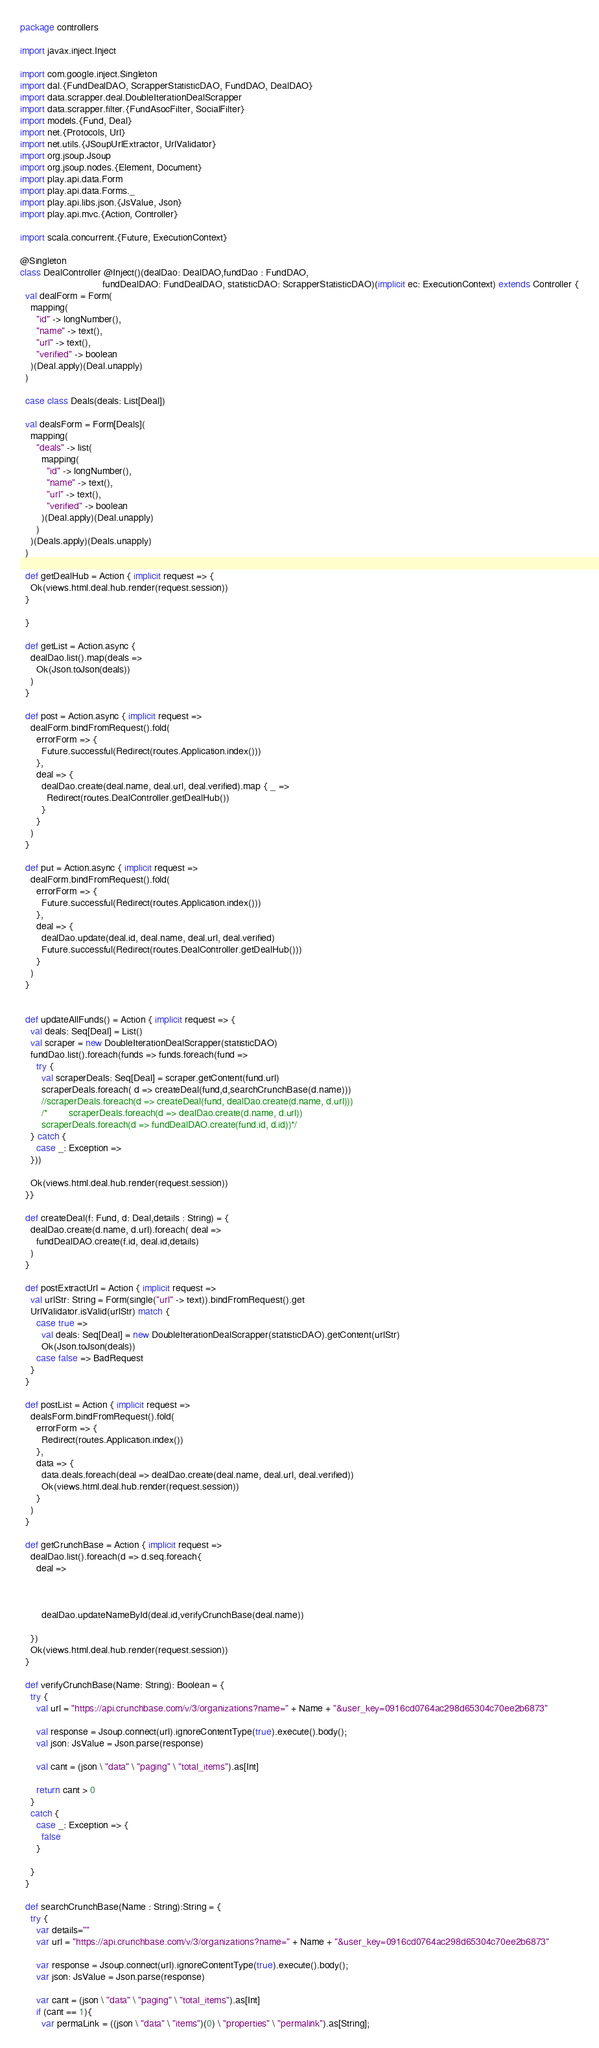Convert code to text. <code><loc_0><loc_0><loc_500><loc_500><_Scala_>package controllers

import javax.inject.Inject

import com.google.inject.Singleton
import dal.{FundDealDAO, ScrapperStatisticDAO, FundDAO, DealDAO}
import data.scrapper.deal.DoubleIterationDealScrapper
import data.scrapper.filter.{FundAsocFilter, SocialFilter}
import models.{Fund, Deal}
import net.{Protocols, Url}
import net.utils.{JSoupUrlExtractor, UrlValidator}
import org.jsoup.Jsoup
import org.jsoup.nodes.{Element, Document}
import play.api.data.Form
import play.api.data.Forms._
import play.api.libs.json.{JsValue, Json}
import play.api.mvc.{Action, Controller}

import scala.concurrent.{Future, ExecutionContext}

@Singleton
class DealController @Inject()(dealDao: DealDAO,fundDao : FundDAO,
                               fundDealDAO: FundDealDAO, statisticDAO: ScrapperStatisticDAO)(implicit ec: ExecutionContext) extends Controller {
  val dealForm = Form(
    mapping(
      "id" -> longNumber(),
      "name" -> text(),
      "url" -> text(),
      "verified" -> boolean
    )(Deal.apply)(Deal.unapply)
  )

  case class Deals(deals: List[Deal])

  val dealsForm = Form[Deals](
    mapping(
      "deals" -> list(
        mapping(
          "id" -> longNumber(),
          "name" -> text(),
          "url" -> text(),
          "verified" -> boolean
        )(Deal.apply)(Deal.unapply)
      )
    )(Deals.apply)(Deals.unapply)
  )

  def getDealHub = Action { implicit request => {
    Ok(views.html.deal.hub.render(request.session))
  }

  }

  def getList = Action.async {
    dealDao.list().map(deals =>
      Ok(Json.toJson(deals))
    )
  }

  def post = Action.async { implicit request =>
    dealForm.bindFromRequest().fold(
      errorForm => {
        Future.successful(Redirect(routes.Application.index()))
      },
      deal => {
        dealDao.create(deal.name, deal.url, deal.verified).map { _ =>
          Redirect(routes.DealController.getDealHub())
        }
      }
    )
  }

  def put = Action.async { implicit request =>
    dealForm.bindFromRequest().fold(
      errorForm => {
        Future.successful(Redirect(routes.Application.index()))
      },
      deal => {
        dealDao.update(deal.id, deal.name, deal.url, deal.verified)
        Future.successful(Redirect(routes.DealController.getDealHub()))
      }
    )
  }


  def updateAllFunds() = Action { implicit request => {
    val deals: Seq[Deal] = List()
    val scraper = new DoubleIterationDealScrapper(statisticDAO)
    fundDao.list().foreach(funds => funds.foreach(fund =>
      try {
        val scraperDeals: Seq[Deal] = scraper.getContent(fund.url)
        scraperDeals.foreach( d => createDeal(fund,d,searchCrunchBase(d.name)))
        //scraperDeals.foreach(d => createDeal(fund, dealDao.create(d.name, d.url)))
        /*        scraperDeals.foreach(d => dealDao.create(d.name, d.url))
        scraperDeals.foreach(d => fundDealDAO.create(fund.id, d.id))*/
    } catch {
      case _: Exception =>
    }))

    Ok(views.html.deal.hub.render(request.session))
  }}

  def createDeal(f: Fund, d: Deal,details : String) = {
    dealDao.create(d.name, d.url).foreach( deal =>
      fundDealDAO.create(f.id, deal.id,details)
    )
  }

  def postExtractUrl = Action { implicit request =>
    val urlStr: String = Form(single("url" -> text)).bindFromRequest().get
    UrlValidator.isValid(urlStr) match {
      case true =>
        val deals: Seq[Deal] = new DoubleIterationDealScrapper(statisticDAO).getContent(urlStr)
        Ok(Json.toJson(deals))
      case false => BadRequest
    }
  }

  def postList = Action { implicit request =>
    dealsForm.bindFromRequest().fold(
      errorForm => {
        Redirect(routes.Application.index())
      },
      data => {
        data.deals.foreach(deal => dealDao.create(deal.name, deal.url, deal.verified))
        Ok(views.html.deal.hub.render(request.session))
      }
    )
  }

  def getCrunchBase = Action { implicit request =>
    dealDao.list().foreach(d => d.seq.foreach{
      deal =>



        dealDao.updateNameById(deal.id,verifyCrunchBase(deal.name))

    })
    Ok(views.html.deal.hub.render(request.session))
  }

  def verifyCrunchBase(Name: String): Boolean = {
    try {
      val url = "https://api.crunchbase.com/v/3/organizations?name=" + Name + "&user_key=0916cd0764ac298d65304c70ee2b6873"

      val response = Jsoup.connect(url).ignoreContentType(true).execute().body();
      val json: JsValue = Json.parse(response)

      val cant = (json \ "data" \ "paging" \ "total_items").as[Int]

      return cant > 0
    }
    catch {
      case _: Exception => {
        false
      }

    }
  }

  def searchCrunchBase(Name : String):String = {
    try {
      var details=""
      var url = "https://api.crunchbase.com/v/3/organizations?name=" + Name + "&user_key=0916cd0764ac298d65304c70ee2b6873"

      var response = Jsoup.connect(url).ignoreContentType(true).execute().body();
      var json: JsValue = Json.parse(response)

      var cant = (json \ "data" \ "paging" \ "total_items").as[Int]
      if (cant == 1){
        var permaLink = ((json \ "data" \ "items")(0) \ "properties" \ "permalink").as[String];</code> 